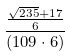<formula> <loc_0><loc_0><loc_500><loc_500>\frac { \frac { \sqrt { 2 3 5 } + 1 7 } { 6 } } { ( 1 0 9 \cdot 6 ) }</formula> 